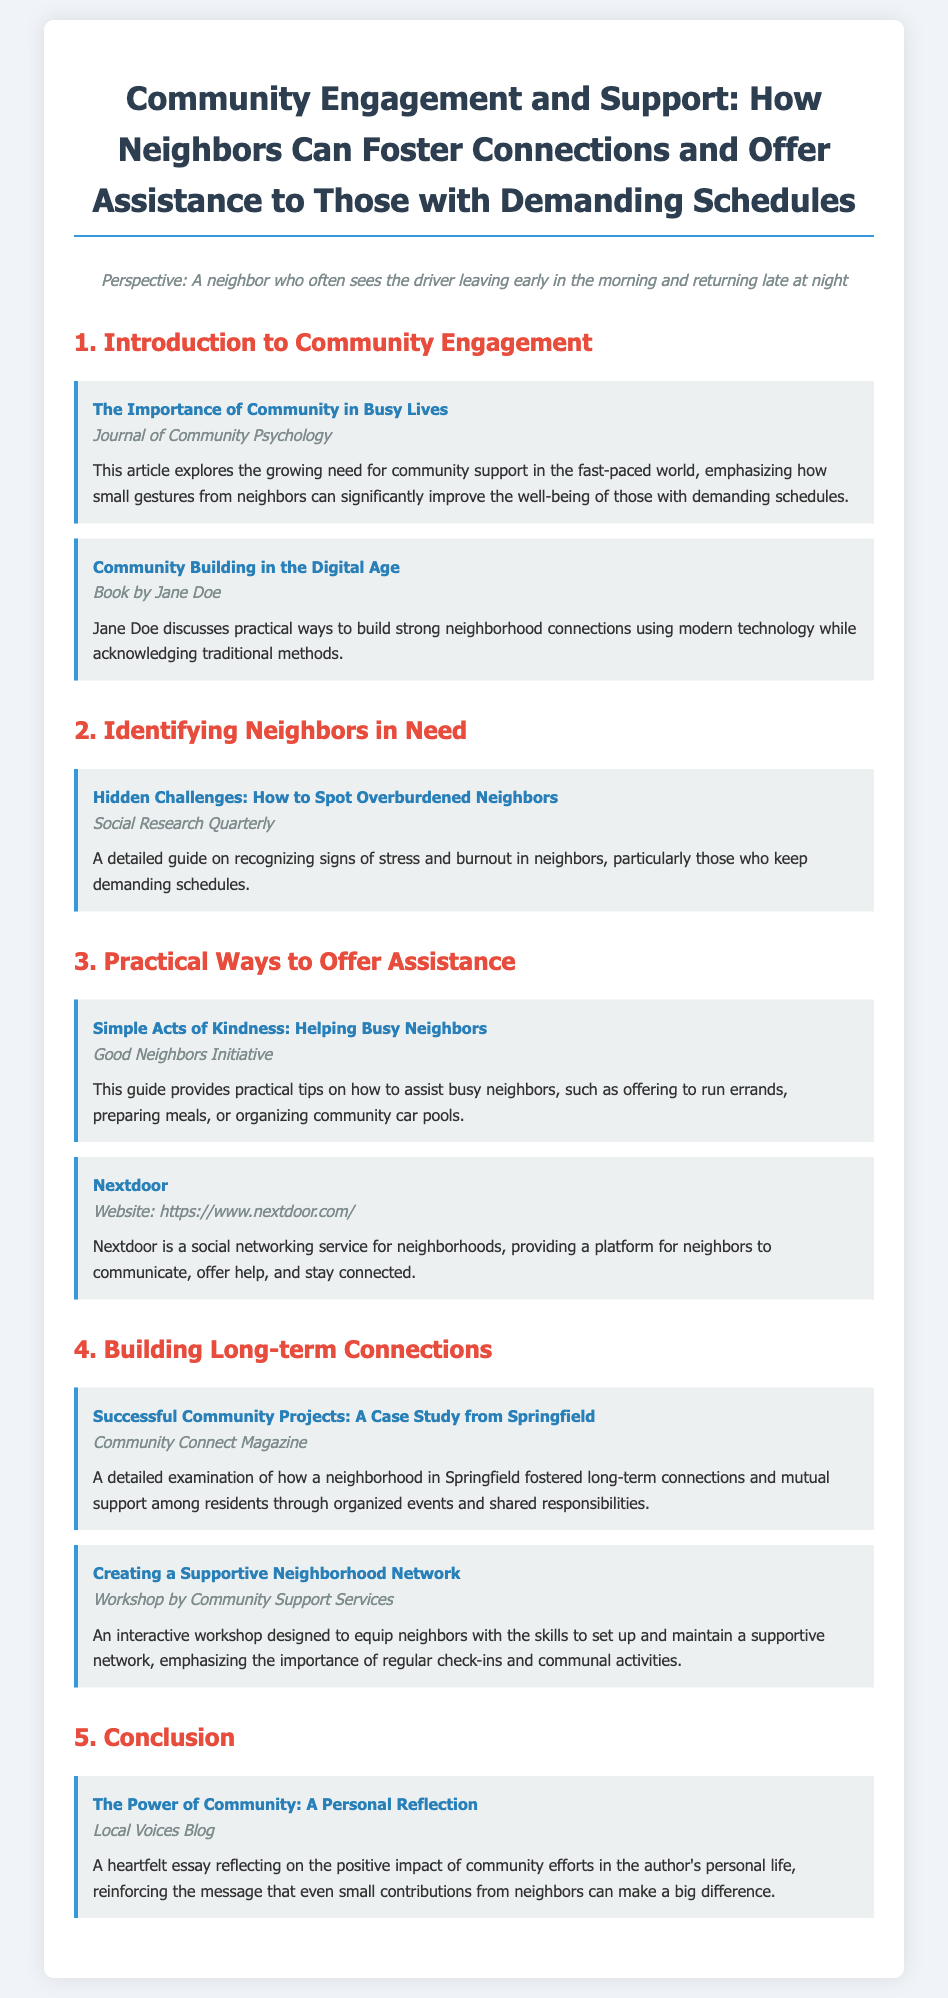what is the title of the syllabus? The title appears at the top of the document and describes the main theme of the syllabus.
Answer: Community Engagement and Support: How Neighbors Can Foster Connections and Offer Assistance to Those with Demanding Schedules who authored the article on recognizing signs of stress? The article on recognizing signs of stress and burnout is attributed to a specific journal.
Answer: Social Research Quarterly what does the "Good Neighbors Initiative" guide provide? The guide outlines practical advice on assisting busy neighbors.
Answer: practical tips on how to assist busy neighbors which magazine examined a community project in Springfield? The case study related to Springfield is published in a specific magazine focused on community topics.
Answer: Community Connect Magazine what is the main topic of the "Creating a Supportive Neighborhood Network" workshop? The workshop's focus is mentioned in the description section, emphasizing a particular skill or importance.
Answer: setting up and maintaining a supportive network how is "Nextdoor" described in the syllabus? The description details what Nextdoor is and its purpose within the community.
Answer: a social networking service for neighborhoods what year does the article in the Journal of Community Psychology emphasize small gestures? The article specifies themes relevant to community support and the intricacies of busy lives, but the year is not mentioned.
Answer: current times (the year is not specified) what type of conclusions does the "Local Voices Blog" present? The blog reflects on the community's impact on personal experiences, which is outlined in the conclusion section.
Answer: personal reflection 